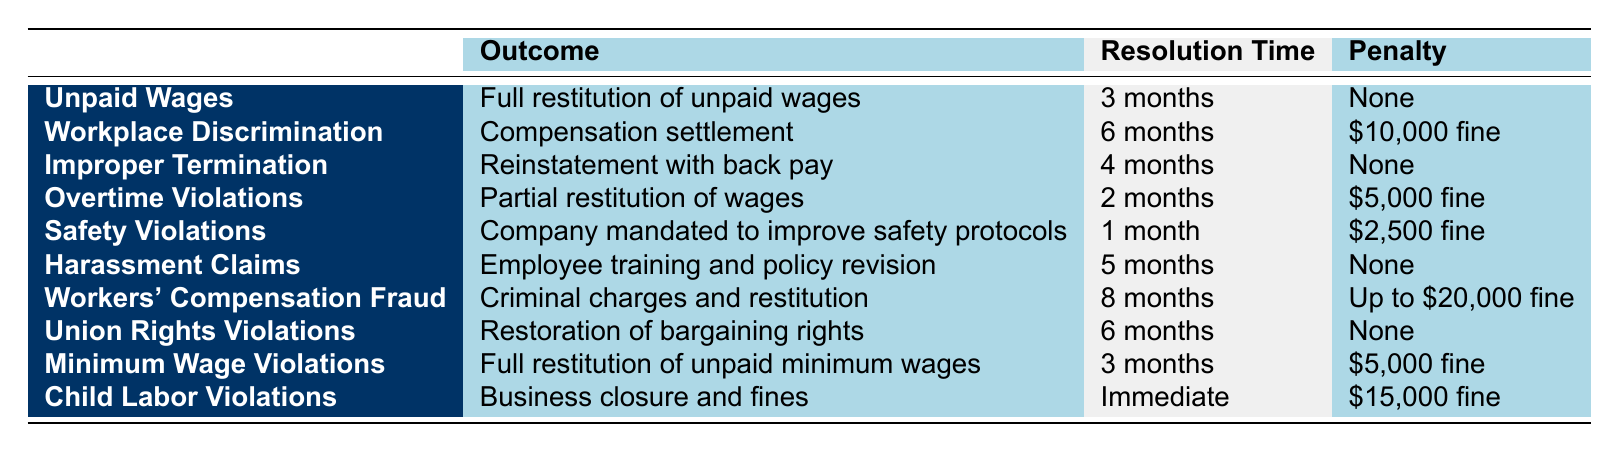What is the outcome for Workplace Discrimination cases? The table lists the outcome for Workplace Discrimination as a "Compensation settlement."
Answer: Compensation settlement How long does it take to resolve Safety Violations cases? According to the table, Safety Violations cases are resolved in "1 month."
Answer: 1 month Is there a penalty for Unpaid Wages cases? The table indicates that there is "None" for the penalty associated with Unpaid Wages cases.
Answer: No What is the average resolution time for cases with a penalty? First, we identify the cases with a penalty: Workplace Discrimination (6 months), Overtime Violations (2 months), Safety Violations (1 month), Minimum Wage Violations (3 months), Child Labor Violations (Immediate), Workers' Compensation Fraud (8 months). We convert "Immediate" to 0 months for calculation. The sum is 6 + 2 + 1 + 3 + 0 + 8 = 20 months. There are 5 applicable cases, so the average is 20/5 = 4 months.
Answer: 4 months Are Improper Termination cases resolved faster than Harassment Claims cases? The resolution time for Improper Termination is "4 months," while Harassment Claims take "5 months." Since 4 is less than 5, Improper Termination cases are resolved faster.
Answer: Yes What penalty is associated with Child Labor Violations? The table specifies a penalty of "$15,000 fine" for Child Labor Violations.
Answer: $15,000 fine Which case type takes the longest to resolve? By reviewing the resolution times, Workers' Compensation Fraud has the longest resolution time at "8 months."
Answer: Workers' Compensation Fraud Is the penalty for Minimum Wage Violations higher than that for Safety Violations? The table indicates that Minimum Wage Violations have a penalty of "$5,000 fine," while Safety Violations carry a penalty of "$2,500 fine." Since $5,000 is greater than $2,500, the penalty for Minimum Wage Violations is higher.
Answer: Yes 